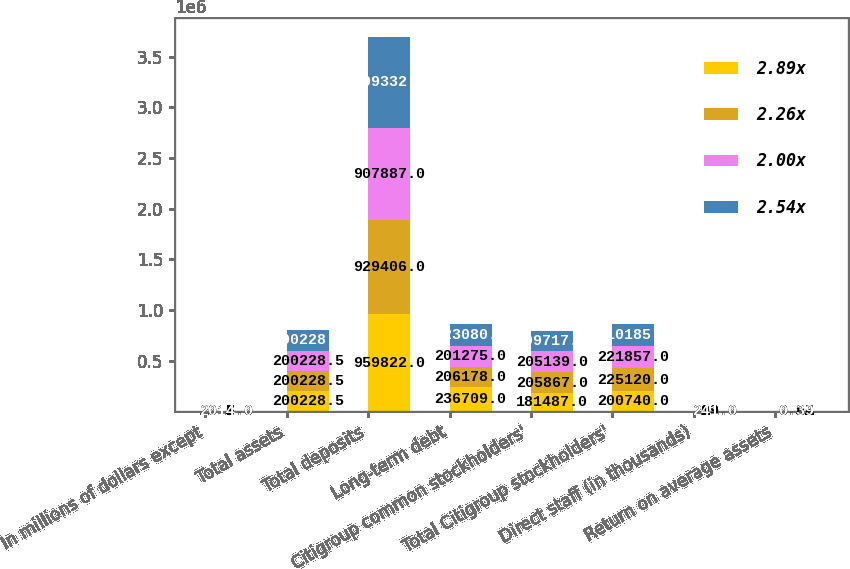<chart> <loc_0><loc_0><loc_500><loc_500><stacked_bar_chart><ecel><fcel>In millions of dollars except<fcel>Total assets<fcel>Total deposits<fcel>Long-term debt<fcel>Citigroup common stockholders'<fcel>Total Citigroup stockholders'<fcel>Direct staff (in thousands)<fcel>Return on average assets<nl><fcel>2.89x<fcel>2017<fcel>200228<fcel>959822<fcel>236709<fcel>181487<fcel>200740<fcel>209<fcel>0.36<nl><fcel>2.26x<fcel>2016<fcel>200228<fcel>929406<fcel>206178<fcel>205867<fcel>225120<fcel>219<fcel>0.82<nl><fcel>2.00x<fcel>2015<fcel>200228<fcel>907887<fcel>201275<fcel>205139<fcel>221857<fcel>231<fcel>0.95<nl><fcel>2.54x<fcel>2014<fcel>200228<fcel>899332<fcel>223080<fcel>199717<fcel>210185<fcel>241<fcel>0.39<nl></chart> 